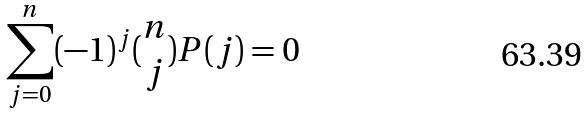Convert formula to latex. <formula><loc_0><loc_0><loc_500><loc_500>\sum _ { j = 0 } ^ { n } ( - 1 ) ^ { j } ( \begin{matrix} n \\ j \end{matrix} ) P ( j ) = 0</formula> 